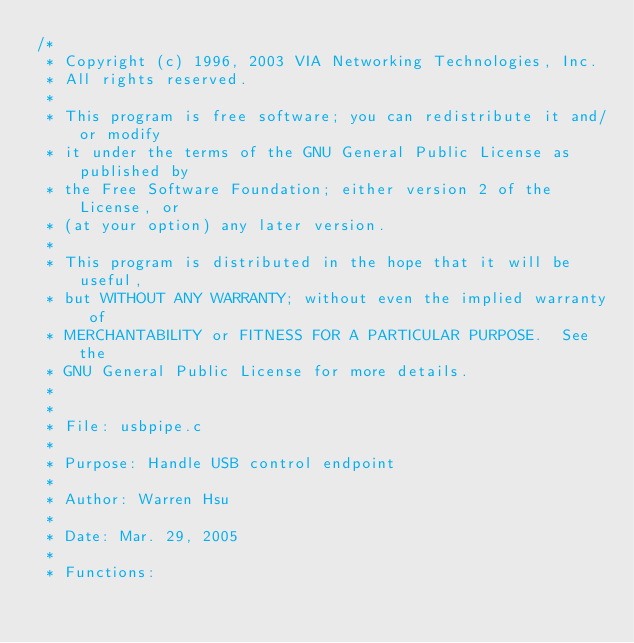Convert code to text. <code><loc_0><loc_0><loc_500><loc_500><_C_>/*
 * Copyright (c) 1996, 2003 VIA Networking Technologies, Inc.
 * All rights reserved.
 *
 * This program is free software; you can redistribute it and/or modify
 * it under the terms of the GNU General Public License as published by
 * the Free Software Foundation; either version 2 of the License, or
 * (at your option) any later version.
 *
 * This program is distributed in the hope that it will be useful,
 * but WITHOUT ANY WARRANTY; without even the implied warranty of
 * MERCHANTABILITY or FITNESS FOR A PARTICULAR PURPOSE.  See the
 * GNU General Public License for more details.
 *
 *
 * File: usbpipe.c
 *
 * Purpose: Handle USB control endpoint
 *
 * Author: Warren Hsu
 *
 * Date: Mar. 29, 2005
 *
 * Functions:</code> 